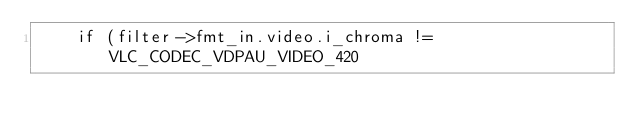<code> <loc_0><loc_0><loc_500><loc_500><_C_>    if (filter->fmt_in.video.i_chroma != VLC_CODEC_VDPAU_VIDEO_420</code> 